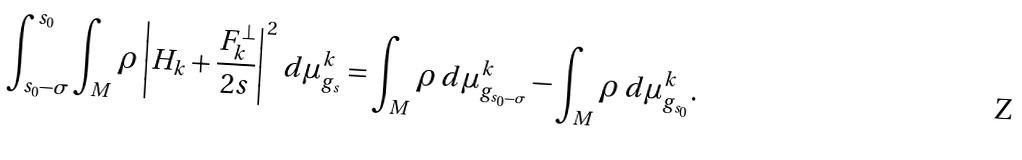<formula> <loc_0><loc_0><loc_500><loc_500>\int _ { s _ { 0 } - \sigma } ^ { s _ { 0 } } \int _ { M } \rho \left | H _ { k } + \frac { F _ { k } ^ { \bot } } { 2 s } \right | ^ { 2 } \, d \mu _ { g _ { s } } ^ { k } = \int _ { M } \rho \, d \mu _ { g _ { s _ { 0 } - \sigma } } ^ { k } - \int _ { M } \rho \, d \mu _ { g _ { s _ { 0 } } } ^ { k } .</formula> 